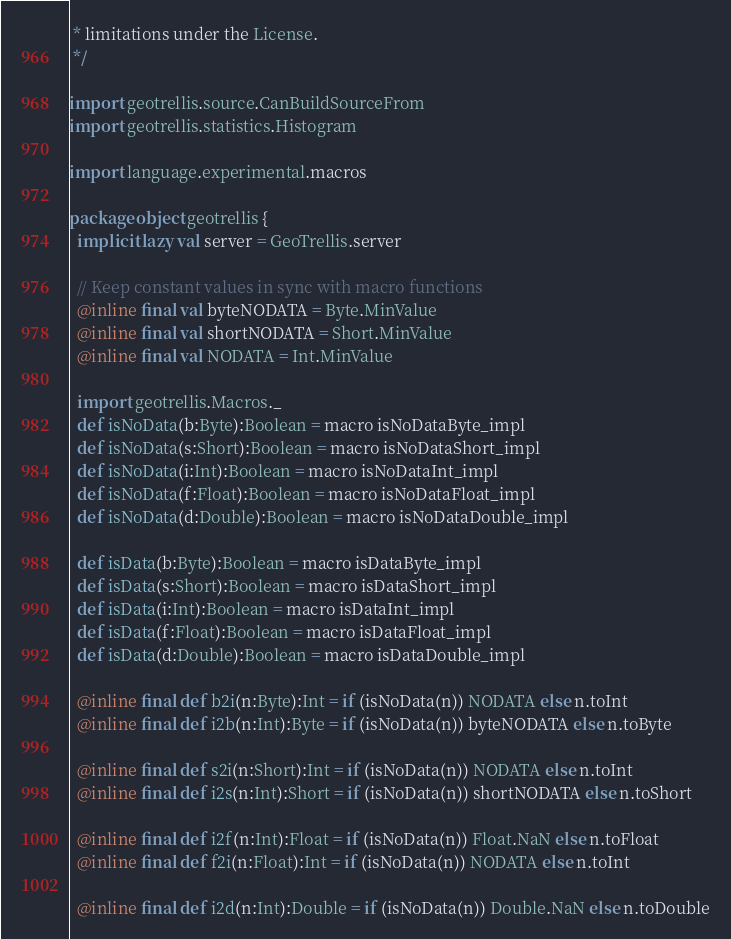<code> <loc_0><loc_0><loc_500><loc_500><_Scala_> * limitations under the License.
 */

import geotrellis.source.CanBuildSourceFrom
import geotrellis.statistics.Histogram

import language.experimental.macros

package object geotrellis {
  implicit lazy val server = GeoTrellis.server

  // Keep constant values in sync with macro functions
  @inline final val byteNODATA = Byte.MinValue 
  @inline final val shortNODATA = Short.MinValue
  @inline final val NODATA = Int.MinValue

  import geotrellis.Macros._
  def isNoData(b:Byte):Boolean = macro isNoDataByte_impl
  def isNoData(s:Short):Boolean = macro isNoDataShort_impl
  def isNoData(i:Int):Boolean = macro isNoDataInt_impl
  def isNoData(f:Float):Boolean = macro isNoDataFloat_impl
  def isNoData(d:Double):Boolean = macro isNoDataDouble_impl

  def isData(b:Byte):Boolean = macro isDataByte_impl
  def isData(s:Short):Boolean = macro isDataShort_impl
  def isData(i:Int):Boolean = macro isDataInt_impl
  def isData(f:Float):Boolean = macro isDataFloat_impl
  def isData(d:Double):Boolean = macro isDataDouble_impl

  @inline final def b2i(n:Byte):Int = if (isNoData(n)) NODATA else n.toInt
  @inline final def i2b(n:Int):Byte = if (isNoData(n)) byteNODATA else n.toByte

  @inline final def s2i(n:Short):Int = if (isNoData(n)) NODATA else n.toInt
  @inline final def i2s(n:Int):Short = if (isNoData(n)) shortNODATA else n.toShort

  @inline final def i2f(n:Int):Float = if (isNoData(n)) Float.NaN else n.toFloat
  @inline final def f2i(n:Float):Int = if (isNoData(n)) NODATA else n.toInt

  @inline final def i2d(n:Int):Double = if (isNoData(n)) Double.NaN else n.toDouble</code> 